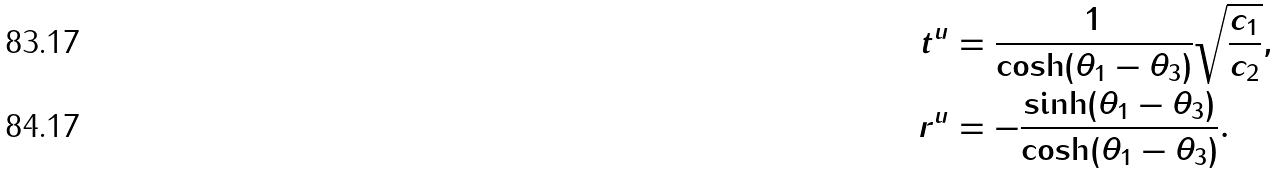Convert formula to latex. <formula><loc_0><loc_0><loc_500><loc_500>t ^ { u } & = \frac { 1 } { \cosh ( \theta _ { 1 } - \theta _ { 3 } ) } \sqrt { \frac { c _ { 1 } } { c _ { 2 } } } , \\ r ^ { u } & = - \frac { \sinh ( \theta _ { 1 } - \theta _ { 3 } ) } { \cosh ( \theta _ { 1 } - \theta _ { 3 } ) } .</formula> 